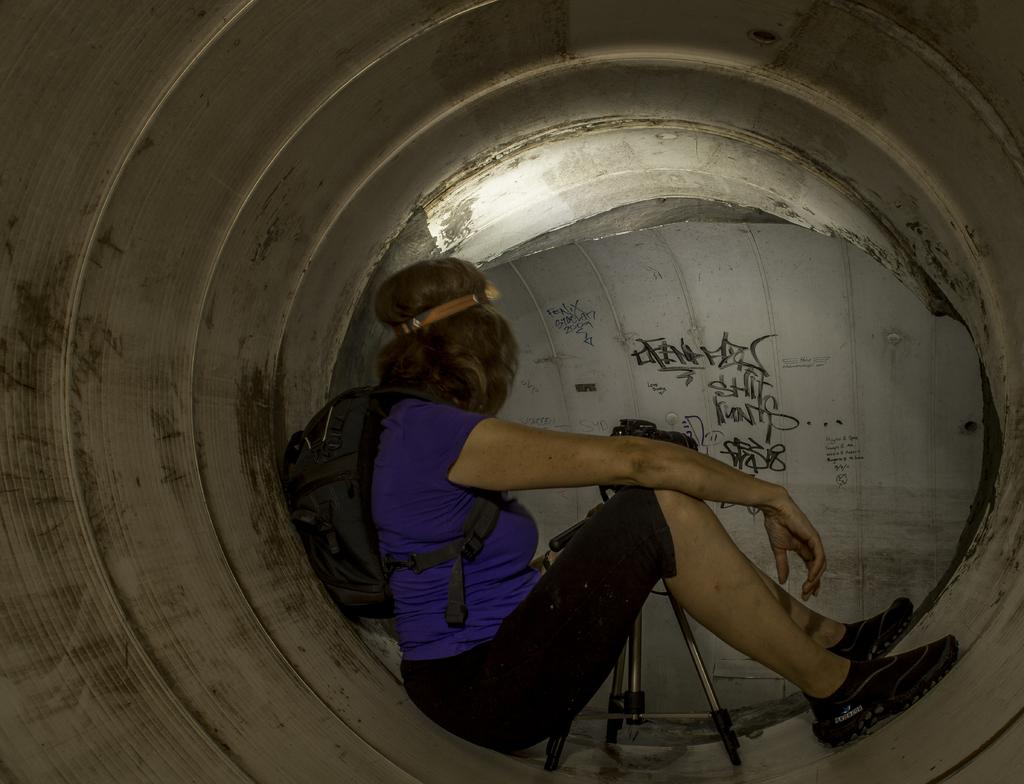What is the main subject of the image? The main subject of the image is a woman. What is the woman wearing in the image? The woman is wearing a bag in the image. What object can be seen in the image that is typically used for capturing images? There is a camera in the image. What type of structure is present in the image? There is a stand in the image. What type of rock can be seen being used in a fight in the image? There is no rock or fight present in the image. What type of club can be seen in the image? There is no club present in the image. 